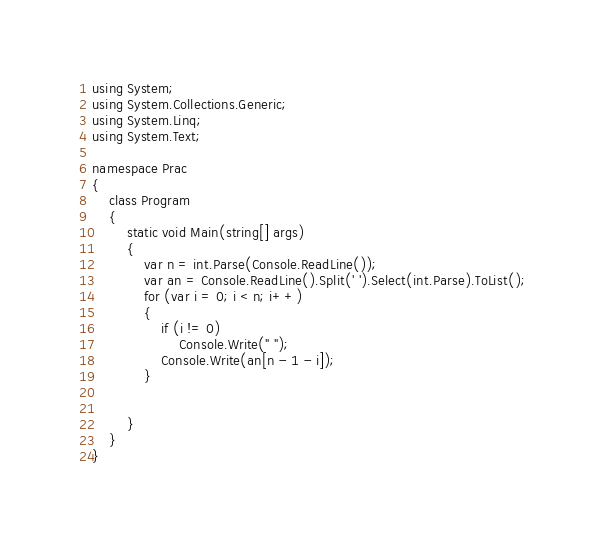Convert code to text. <code><loc_0><loc_0><loc_500><loc_500><_C#_>using System;
using System.Collections.Generic;
using System.Linq;
using System.Text;

namespace Prac
{
    class Program
    {
        static void Main(string[] args)
        {
            var n = int.Parse(Console.ReadLine());
            var an = Console.ReadLine().Split(' ').Select(int.Parse).ToList();
            for (var i = 0; i < n; i++)
            {
                if (i != 0)
                    Console.Write(" ");
                Console.Write(an[n - 1 - i]);
            }


        }
    }
}</code> 